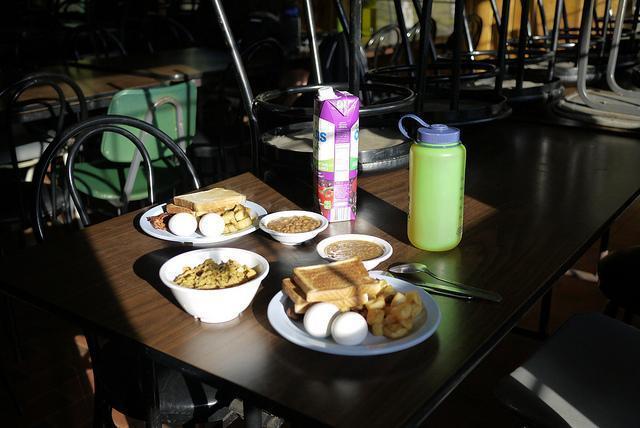How many bowls are on the table?
Give a very brief answer. 3. How many eggs per plate?
Give a very brief answer. 2. How many bowls are visible?
Give a very brief answer. 1. How many chairs can you see?
Give a very brief answer. 11. 